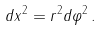Convert formula to latex. <formula><loc_0><loc_0><loc_500><loc_500>d x ^ { 2 } = r ^ { 2 } d \varphi ^ { 2 } \, .</formula> 